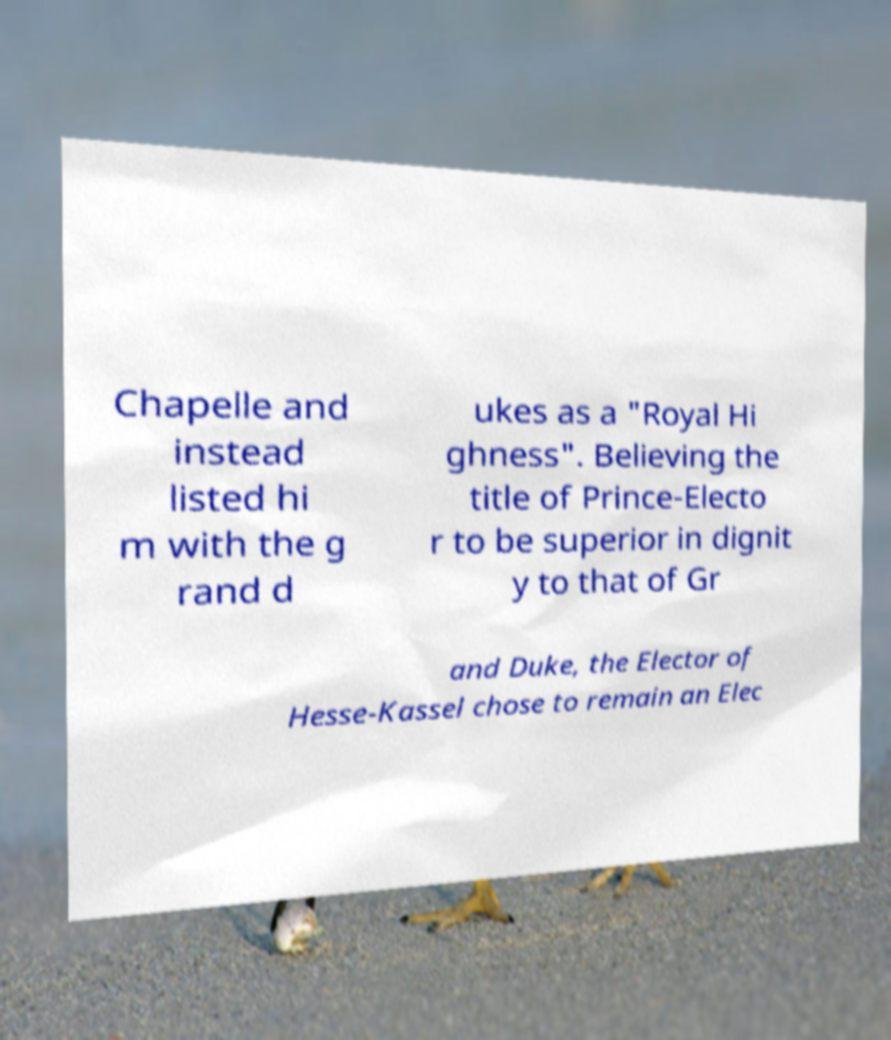Please identify and transcribe the text found in this image. Chapelle and instead listed hi m with the g rand d ukes as a "Royal Hi ghness". Believing the title of Prince-Electo r to be superior in dignit y to that of Gr and Duke, the Elector of Hesse-Kassel chose to remain an Elec 